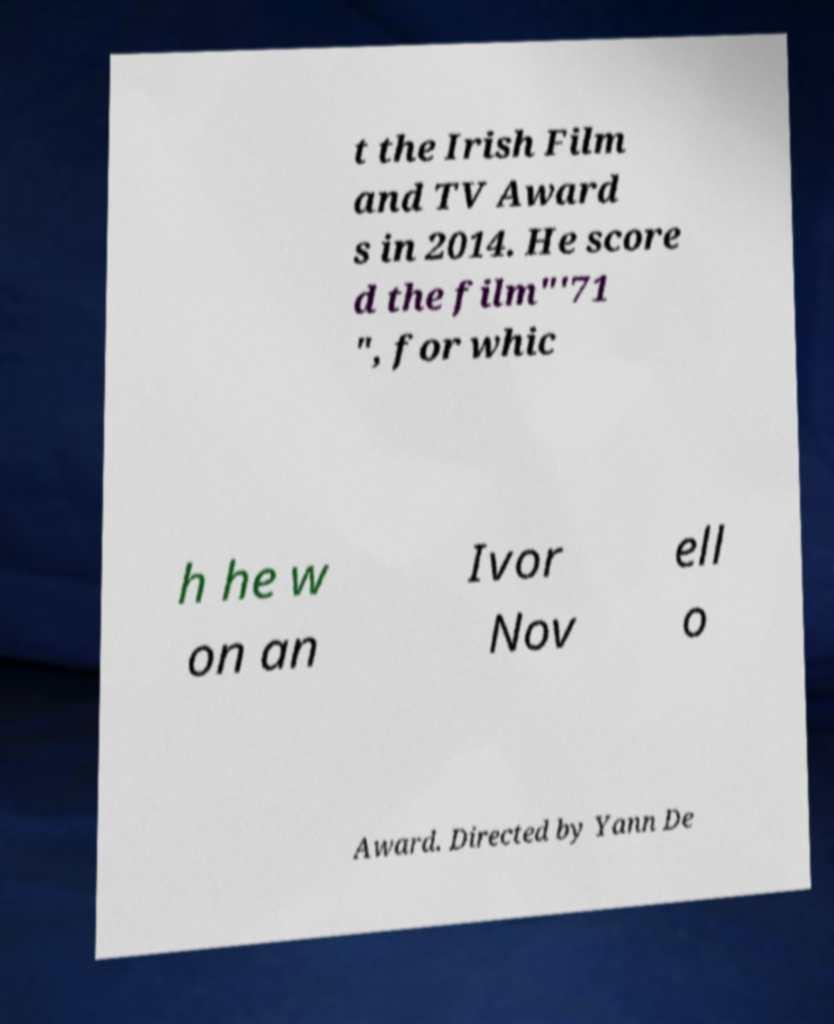Can you read and provide the text displayed in the image?This photo seems to have some interesting text. Can you extract and type it out for me? t the Irish Film and TV Award s in 2014. He score d the film"'71 ", for whic h he w on an Ivor Nov ell o Award. Directed by Yann De 